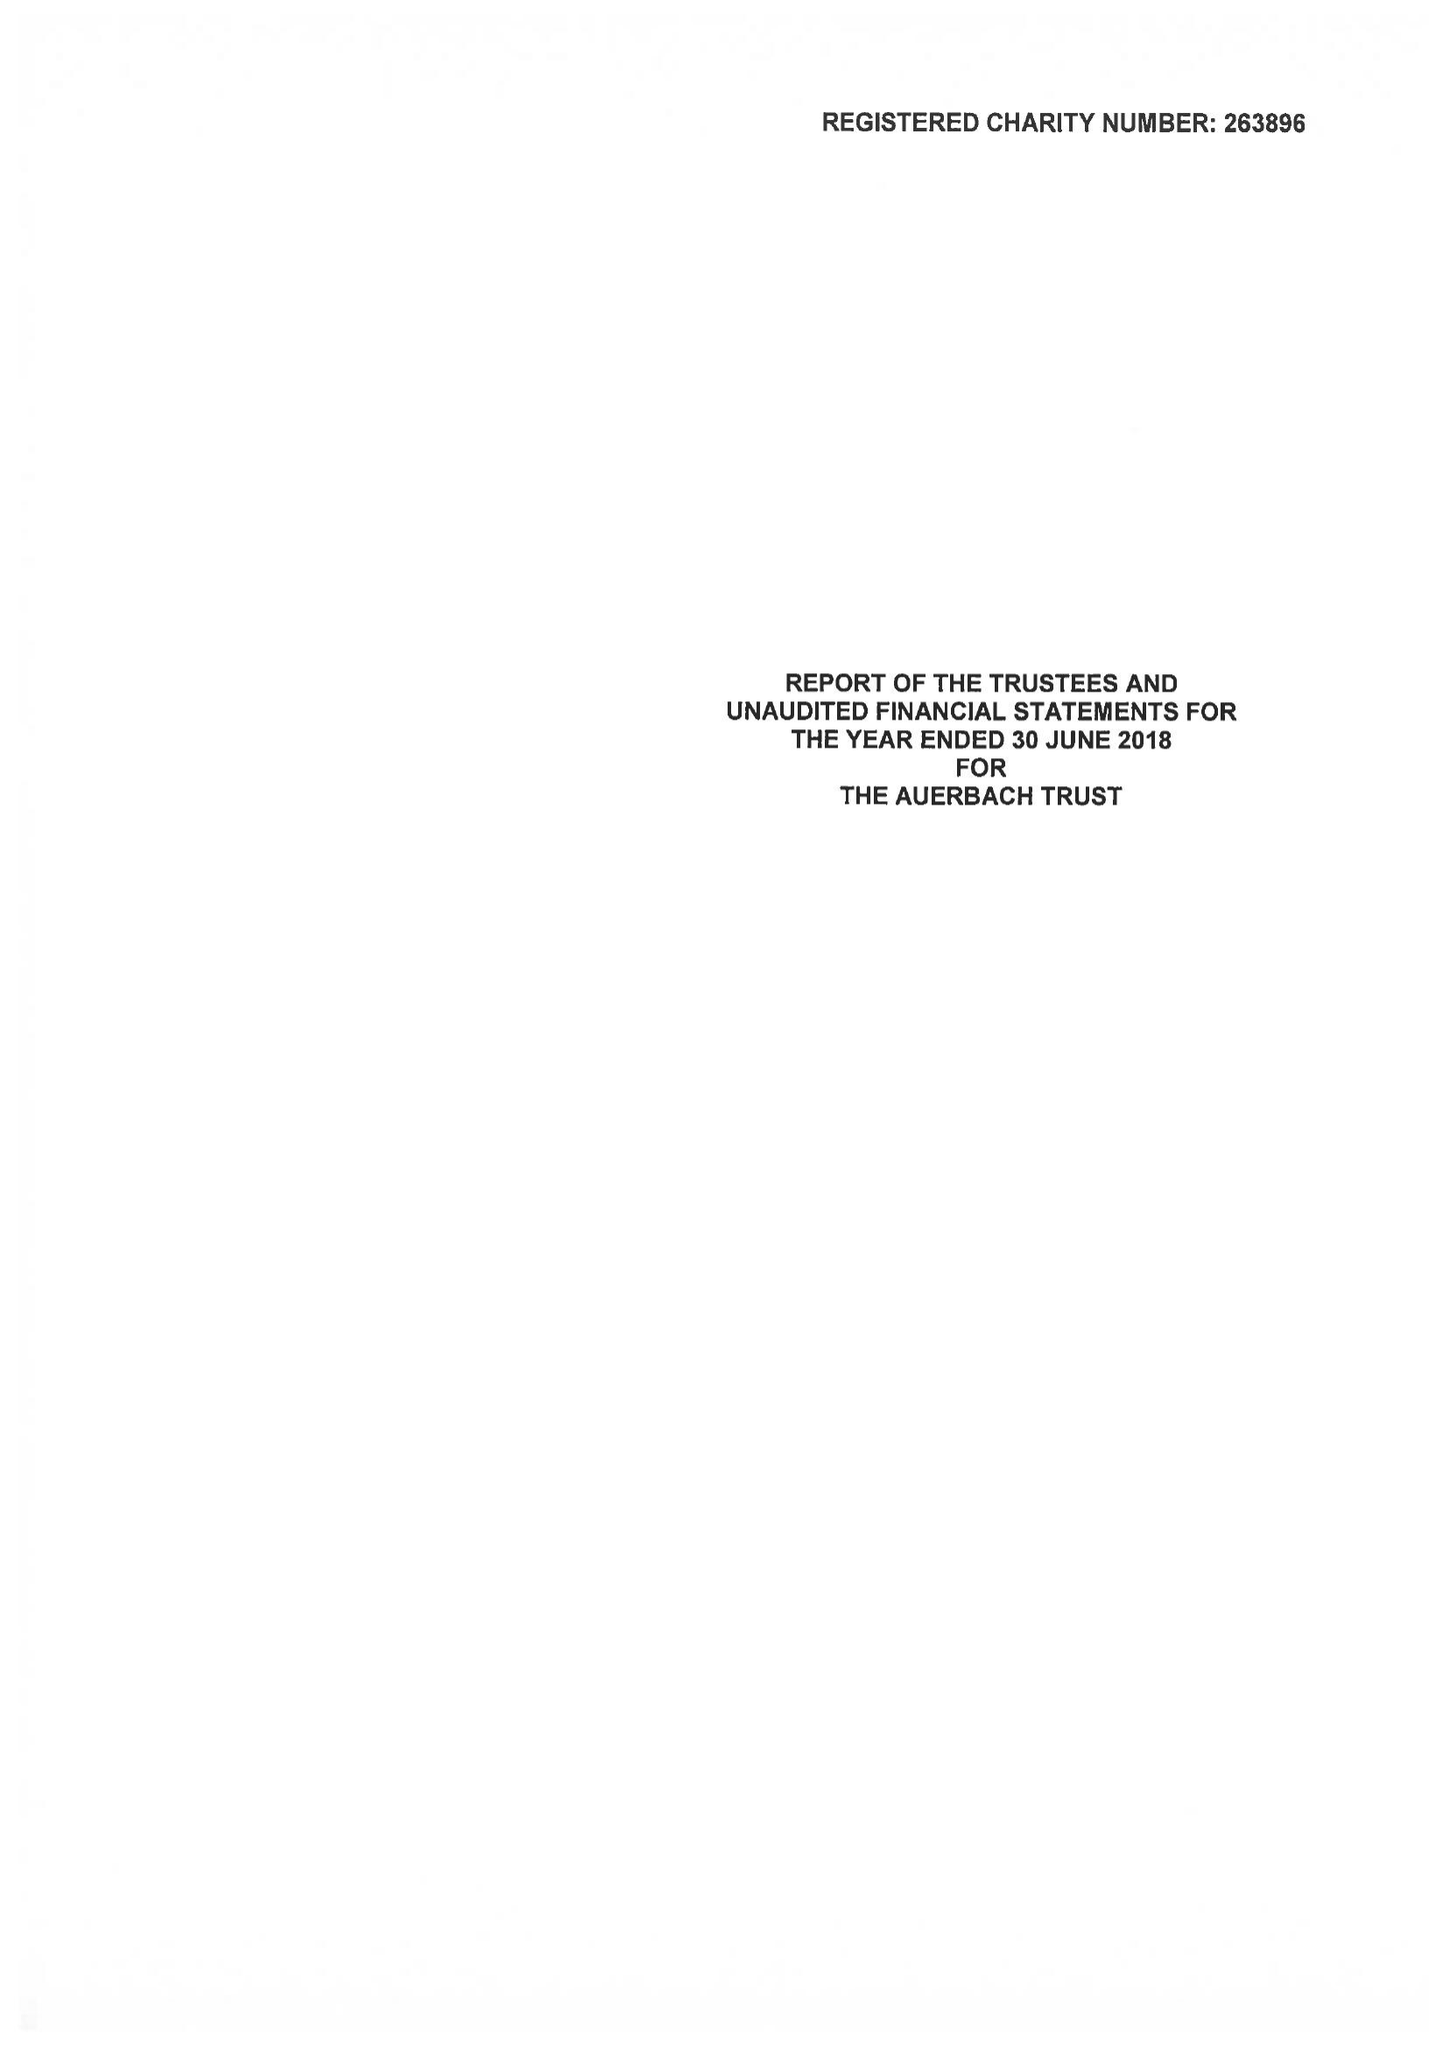What is the value for the address__post_town?
Answer the question using a single word or phrase. LONDON 